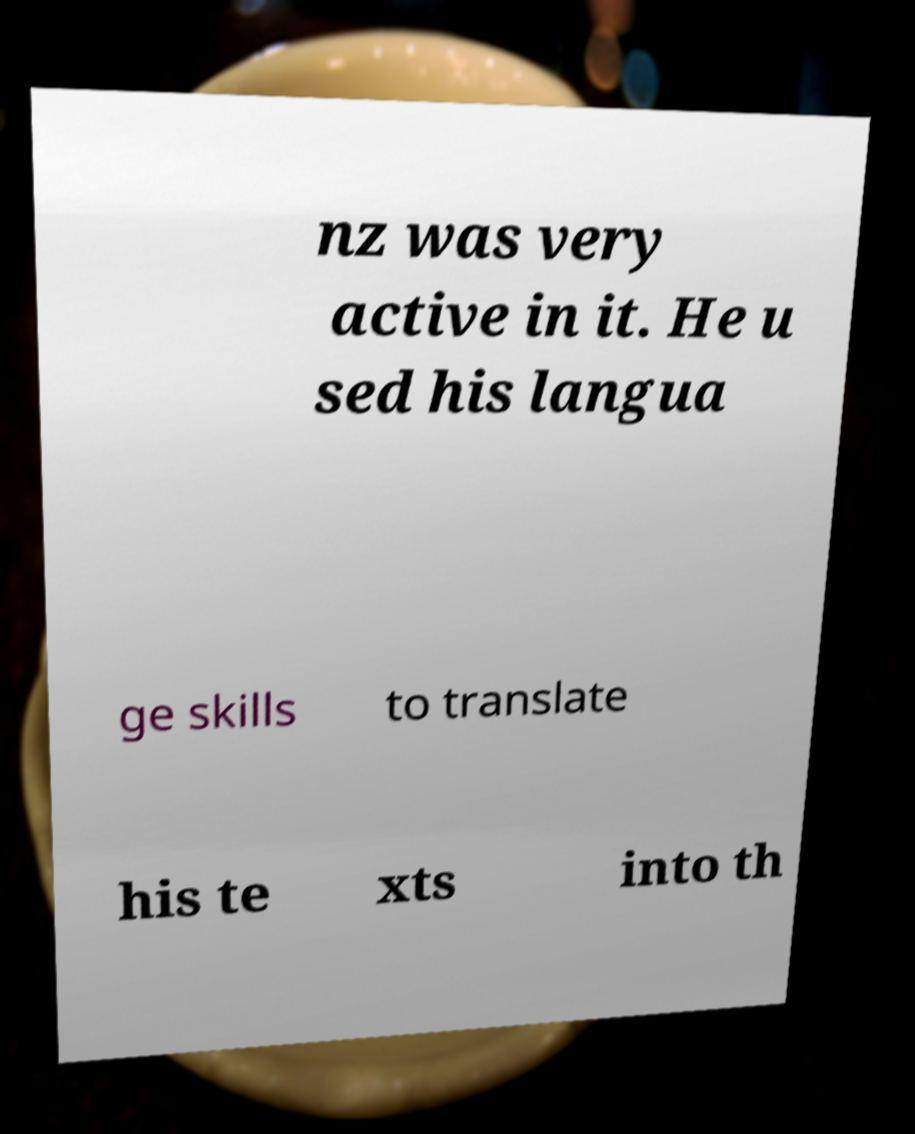What messages or text are displayed in this image? I need them in a readable, typed format. nz was very active in it. He u sed his langua ge skills to translate his te xts into th 